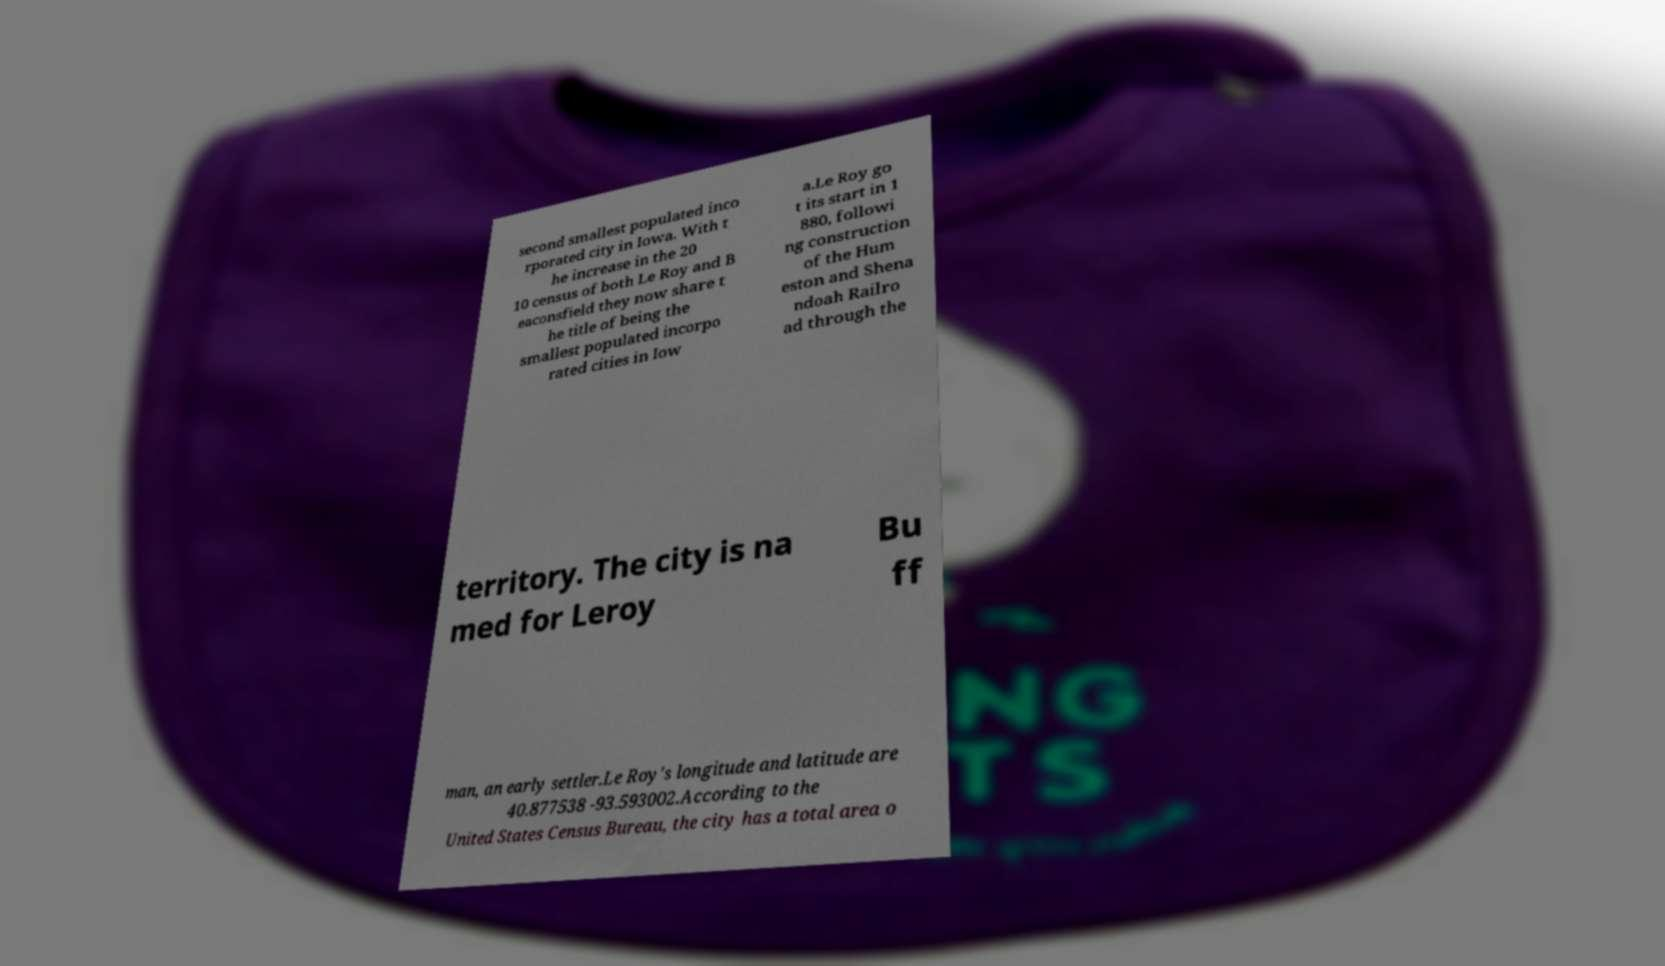Can you read and provide the text displayed in the image?This photo seems to have some interesting text. Can you extract and type it out for me? second smallest populated inco rporated city in Iowa. With t he increase in the 20 10 census of both Le Roy and B eaconsfield they now share t he title of being the smallest populated incorpo rated cities in Iow a.Le Roy go t its start in 1 880, followi ng construction of the Hum eston and Shena ndoah Railro ad through the territory. The city is na med for Leroy Bu ff man, an early settler.Le Roy's longitude and latitude are 40.877538 -93.593002.According to the United States Census Bureau, the city has a total area o 